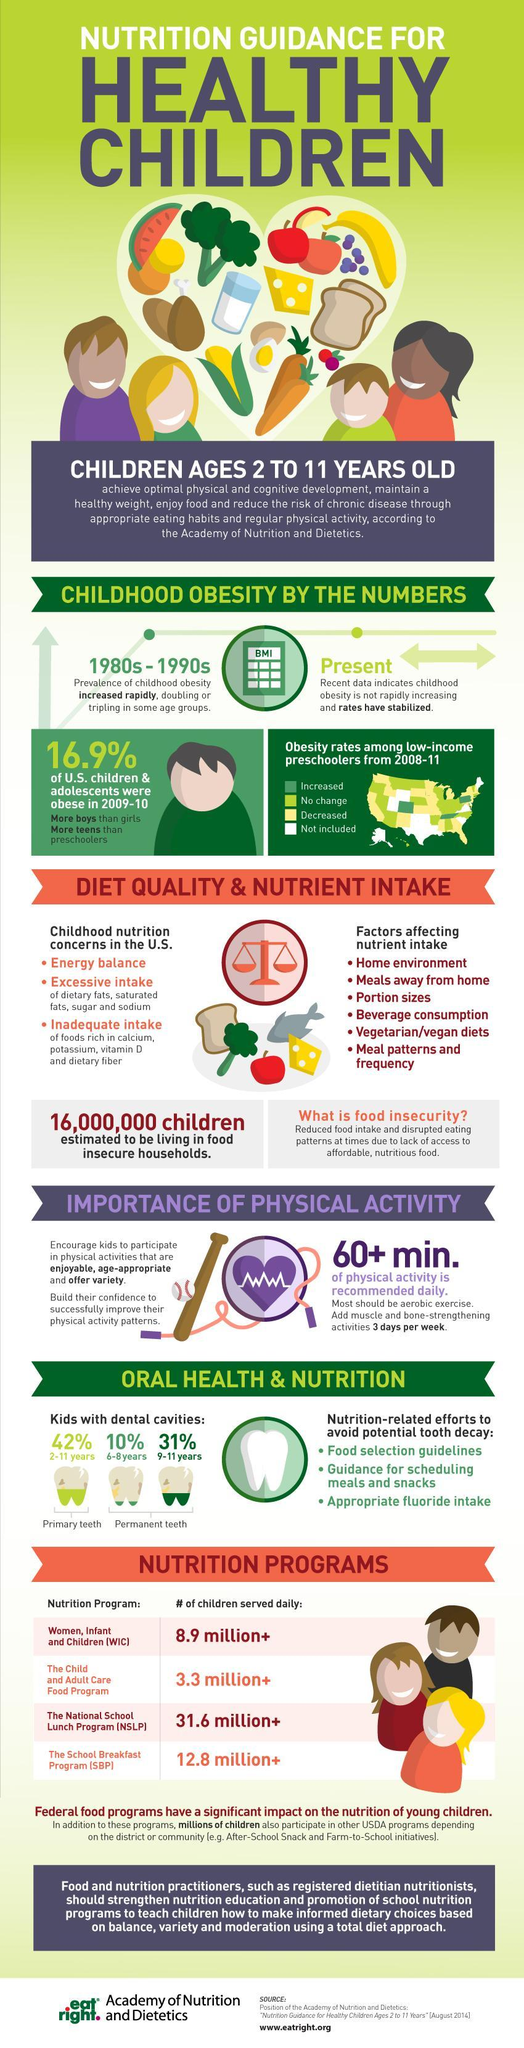How many factors affecting nutrient intake are listed?
Answer the question with a short phrase. 6 What percentage of kids have cavities in primary teeth? 42% What is recommended for at least one hour daily? Physical activity What is the reason for food insecurity or reduced food intake? lack of access to affordable, nutritious food During which time period was there a rapid increase in cases of childhood obesity? 1980s - 1990s In which teeth do 31% of 9-11 year old kids have cavities? permanent teeth What is the third factor that affects nutrient intake? Portion sizes In the map, how many states show increased obesity rates from 2008-11? 3 When does intake of dietary fats, saturated fats, sugar and sodium cause concern ? Excessive intake Foods rich in which all nutrients are being consumed in inadequate amounts? calcium, potassium, vitamin D and dietary fiber 